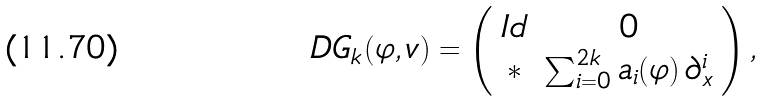<formula> <loc_0><loc_0><loc_500><loc_500>D G _ { k } { ( \varphi , v ) } = \left ( \begin{array} { c c } I d & 0 \\ \ast & \sum _ { i = 0 } ^ { 2 k } a _ { i } ( \varphi ) \, \partial _ { x } ^ { i } \end{array} \right ) ,</formula> 